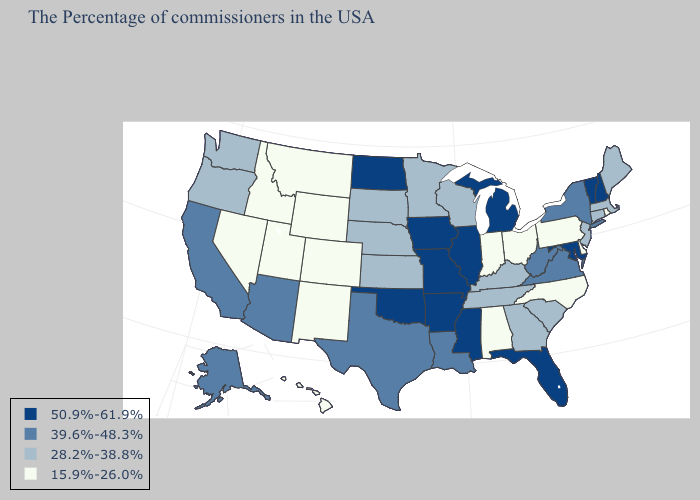What is the lowest value in states that border Colorado?
Keep it brief. 15.9%-26.0%. Name the states that have a value in the range 50.9%-61.9%?
Short answer required. New Hampshire, Vermont, Maryland, Florida, Michigan, Illinois, Mississippi, Missouri, Arkansas, Iowa, Oklahoma, North Dakota. Among the states that border Vermont , which have the lowest value?
Answer briefly. Massachusetts. What is the highest value in states that border Vermont?
Answer briefly. 50.9%-61.9%. Does Louisiana have the highest value in the USA?
Be succinct. No. What is the value of Kansas?
Be succinct. 28.2%-38.8%. Which states hav the highest value in the South?
Be succinct. Maryland, Florida, Mississippi, Arkansas, Oklahoma. What is the highest value in the USA?
Keep it brief. 50.9%-61.9%. What is the value of Utah?
Answer briefly. 15.9%-26.0%. What is the value of Hawaii?
Be succinct. 15.9%-26.0%. What is the lowest value in states that border Utah?
Quick response, please. 15.9%-26.0%. Does the first symbol in the legend represent the smallest category?
Keep it brief. No. Name the states that have a value in the range 39.6%-48.3%?
Concise answer only. New York, Virginia, West Virginia, Louisiana, Texas, Arizona, California, Alaska. Does North Carolina have the same value as Washington?
Give a very brief answer. No. What is the value of California?
Keep it brief. 39.6%-48.3%. 